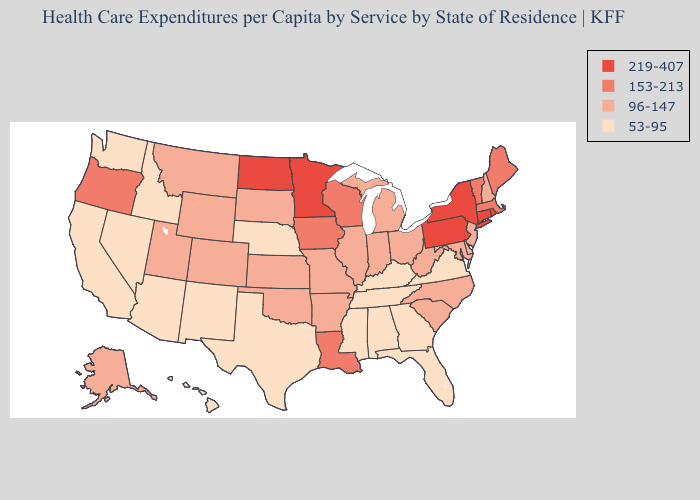What is the lowest value in states that border New York?
Write a very short answer. 96-147. Does West Virginia have the lowest value in the South?
Quick response, please. No. Name the states that have a value in the range 96-147?
Be succinct. Alaska, Arkansas, Colorado, Delaware, Illinois, Indiana, Kansas, Maryland, Michigan, Missouri, Montana, New Hampshire, New Jersey, North Carolina, Ohio, Oklahoma, South Carolina, South Dakota, Utah, West Virginia, Wyoming. What is the highest value in the West ?
Write a very short answer. 153-213. What is the value of Connecticut?
Quick response, please. 219-407. Name the states that have a value in the range 53-95?
Keep it brief. Alabama, Arizona, California, Florida, Georgia, Hawaii, Idaho, Kentucky, Mississippi, Nebraska, Nevada, New Mexico, Tennessee, Texas, Virginia, Washington. Among the states that border California , does Oregon have the lowest value?
Keep it brief. No. What is the value of South Carolina?
Give a very brief answer. 96-147. Name the states that have a value in the range 53-95?
Concise answer only. Alabama, Arizona, California, Florida, Georgia, Hawaii, Idaho, Kentucky, Mississippi, Nebraska, Nevada, New Mexico, Tennessee, Texas, Virginia, Washington. Among the states that border Wyoming , does Idaho have the lowest value?
Quick response, please. Yes. What is the value of Oklahoma?
Keep it brief. 96-147. Does New York have the lowest value in the Northeast?
Keep it brief. No. What is the value of Pennsylvania?
Quick response, please. 219-407. Among the states that border Pennsylvania , which have the highest value?
Keep it brief. New York. What is the lowest value in states that border Wisconsin?
Concise answer only. 96-147. 